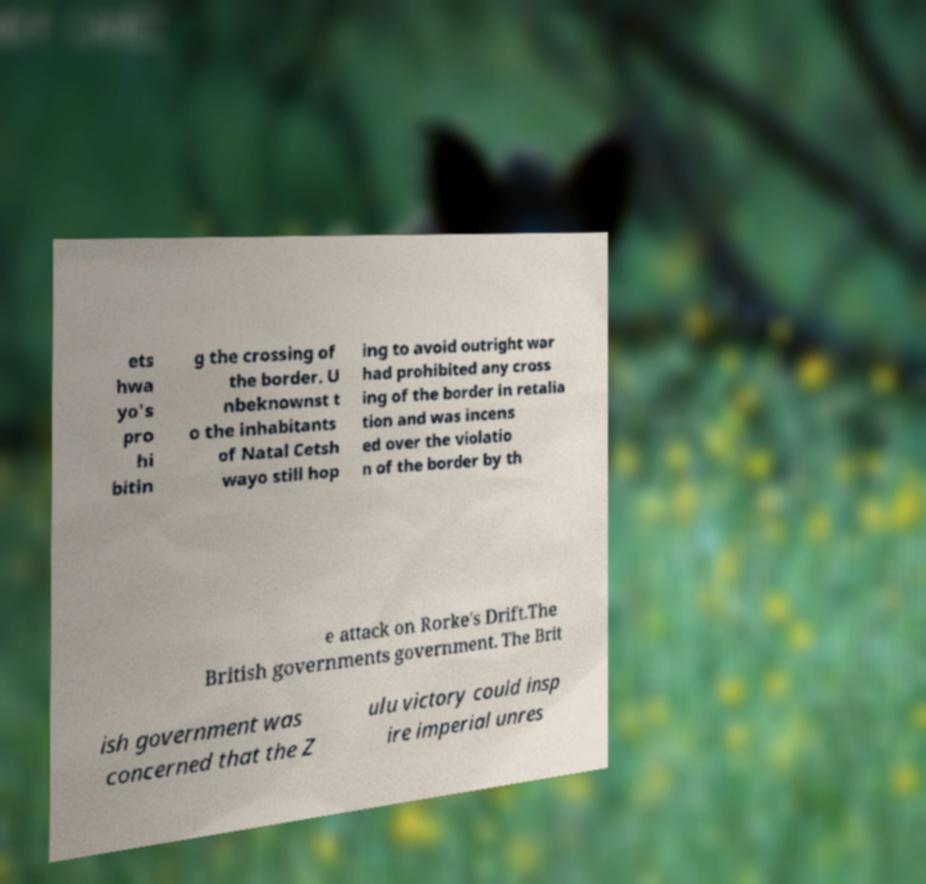For documentation purposes, I need the text within this image transcribed. Could you provide that? ets hwa yo's pro hi bitin g the crossing of the border. U nbeknownst t o the inhabitants of Natal Cetsh wayo still hop ing to avoid outright war had prohibited any cross ing of the border in retalia tion and was incens ed over the violatio n of the border by th e attack on Rorke's Drift.The British governments government. The Brit ish government was concerned that the Z ulu victory could insp ire imperial unres 